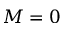<formula> <loc_0><loc_0><loc_500><loc_500>M = 0</formula> 